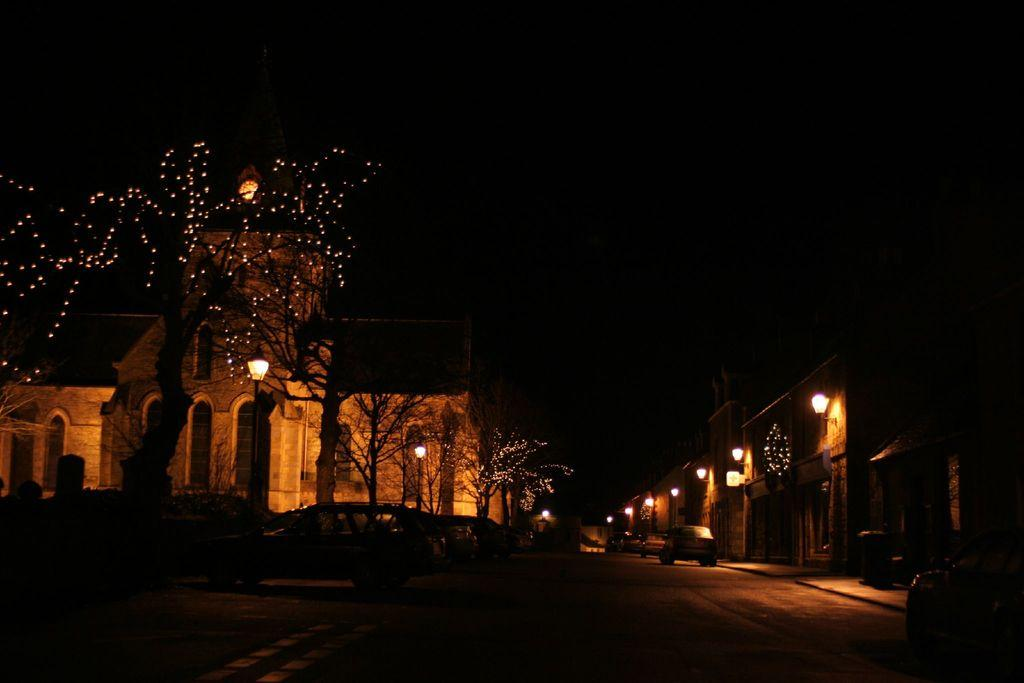What is happening on the road in the image? There are cars on a road in the image. What type of natural elements can be seen in the image? There are trees in the image. What type of artificial lighting is present in the image? There are lights in the image. What structures are used to support the lights in the image? There are light poles in the image. What type of man-made structures are visible in the image? There are buildings in the image. What type of wall can be seen in the downtown area of the image? There is no downtown area or wall present in the image. What type of earth can be seen in the image? The image does not show any earth or soil; it features a road, trees, lights, light poles, and buildings. 